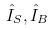Convert formula to latex. <formula><loc_0><loc_0><loc_500><loc_500>\hat { I } _ { S } , \hat { I } _ { B }</formula> 